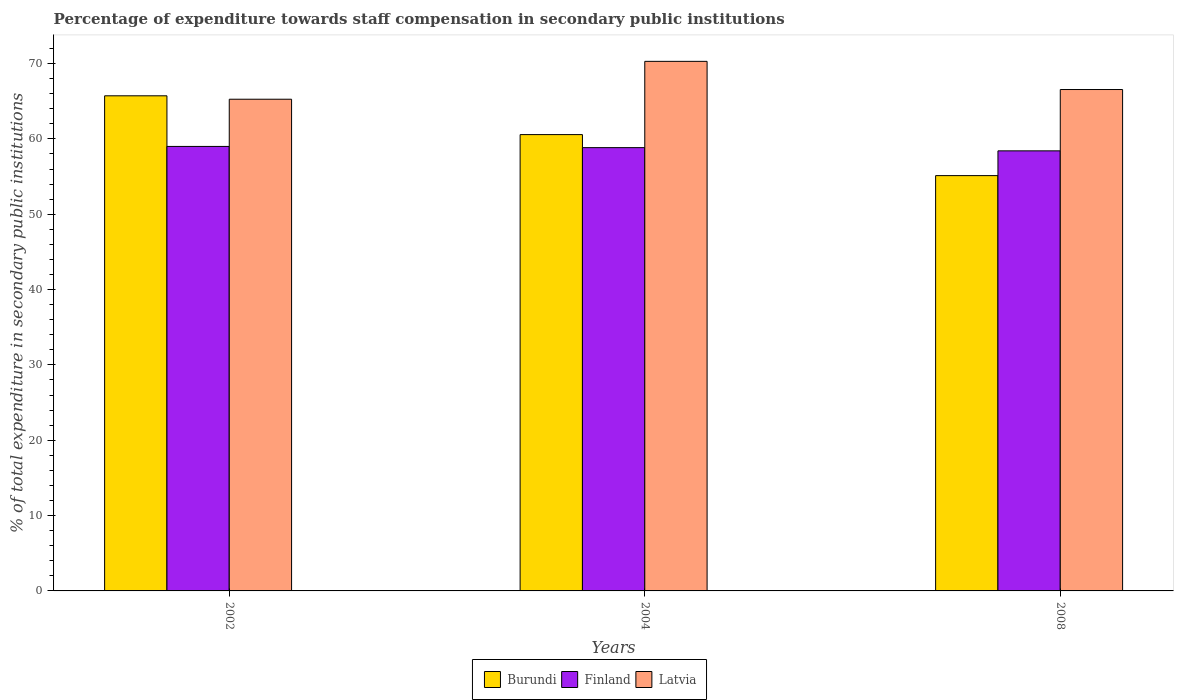How many groups of bars are there?
Ensure brevity in your answer.  3. Are the number of bars per tick equal to the number of legend labels?
Keep it short and to the point. Yes. Are the number of bars on each tick of the X-axis equal?
Make the answer very short. Yes. How many bars are there on the 2nd tick from the right?
Offer a terse response. 3. What is the label of the 3rd group of bars from the left?
Keep it short and to the point. 2008. What is the percentage of expenditure towards staff compensation in Latvia in 2008?
Your response must be concise. 66.56. Across all years, what is the maximum percentage of expenditure towards staff compensation in Burundi?
Make the answer very short. 65.72. Across all years, what is the minimum percentage of expenditure towards staff compensation in Latvia?
Give a very brief answer. 65.27. In which year was the percentage of expenditure towards staff compensation in Burundi maximum?
Offer a terse response. 2002. What is the total percentage of expenditure towards staff compensation in Latvia in the graph?
Make the answer very short. 202.12. What is the difference between the percentage of expenditure towards staff compensation in Finland in 2004 and that in 2008?
Offer a very short reply. 0.43. What is the difference between the percentage of expenditure towards staff compensation in Finland in 2008 and the percentage of expenditure towards staff compensation in Burundi in 2002?
Offer a very short reply. -7.31. What is the average percentage of expenditure towards staff compensation in Latvia per year?
Your answer should be compact. 67.37. In the year 2002, what is the difference between the percentage of expenditure towards staff compensation in Burundi and percentage of expenditure towards staff compensation in Finland?
Provide a succinct answer. 6.72. In how many years, is the percentage of expenditure towards staff compensation in Latvia greater than 54 %?
Your response must be concise. 3. What is the ratio of the percentage of expenditure towards staff compensation in Latvia in 2002 to that in 2004?
Your answer should be very brief. 0.93. Is the percentage of expenditure towards staff compensation in Latvia in 2002 less than that in 2008?
Ensure brevity in your answer.  Yes. What is the difference between the highest and the second highest percentage of expenditure towards staff compensation in Finland?
Provide a short and direct response. 0.16. What is the difference between the highest and the lowest percentage of expenditure towards staff compensation in Latvia?
Keep it short and to the point. 5.03. In how many years, is the percentage of expenditure towards staff compensation in Latvia greater than the average percentage of expenditure towards staff compensation in Latvia taken over all years?
Your answer should be compact. 1. What does the 1st bar from the left in 2002 represents?
Your response must be concise. Burundi. What does the 1st bar from the right in 2004 represents?
Your answer should be very brief. Latvia. Is it the case that in every year, the sum of the percentage of expenditure towards staff compensation in Burundi and percentage of expenditure towards staff compensation in Finland is greater than the percentage of expenditure towards staff compensation in Latvia?
Offer a terse response. Yes. Are all the bars in the graph horizontal?
Provide a short and direct response. No. How many years are there in the graph?
Provide a succinct answer. 3. Does the graph contain any zero values?
Your answer should be very brief. No. Does the graph contain grids?
Give a very brief answer. No. Where does the legend appear in the graph?
Give a very brief answer. Bottom center. What is the title of the graph?
Keep it short and to the point. Percentage of expenditure towards staff compensation in secondary public institutions. What is the label or title of the Y-axis?
Give a very brief answer. % of total expenditure in secondary public institutions. What is the % of total expenditure in secondary public institutions in Burundi in 2002?
Provide a succinct answer. 65.72. What is the % of total expenditure in secondary public institutions of Finland in 2002?
Your answer should be very brief. 59. What is the % of total expenditure in secondary public institutions of Latvia in 2002?
Offer a very short reply. 65.27. What is the % of total expenditure in secondary public institutions of Burundi in 2004?
Your answer should be compact. 60.57. What is the % of total expenditure in secondary public institutions in Finland in 2004?
Give a very brief answer. 58.84. What is the % of total expenditure in secondary public institutions of Latvia in 2004?
Make the answer very short. 70.3. What is the % of total expenditure in secondary public institutions of Burundi in 2008?
Your answer should be very brief. 55.13. What is the % of total expenditure in secondary public institutions in Finland in 2008?
Keep it short and to the point. 58.42. What is the % of total expenditure in secondary public institutions in Latvia in 2008?
Your answer should be very brief. 66.56. Across all years, what is the maximum % of total expenditure in secondary public institutions in Burundi?
Give a very brief answer. 65.72. Across all years, what is the maximum % of total expenditure in secondary public institutions in Finland?
Provide a succinct answer. 59. Across all years, what is the maximum % of total expenditure in secondary public institutions in Latvia?
Give a very brief answer. 70.3. Across all years, what is the minimum % of total expenditure in secondary public institutions of Burundi?
Provide a succinct answer. 55.13. Across all years, what is the minimum % of total expenditure in secondary public institutions in Finland?
Keep it short and to the point. 58.42. Across all years, what is the minimum % of total expenditure in secondary public institutions in Latvia?
Your response must be concise. 65.27. What is the total % of total expenditure in secondary public institutions in Burundi in the graph?
Offer a very short reply. 181.42. What is the total % of total expenditure in secondary public institutions in Finland in the graph?
Ensure brevity in your answer.  176.26. What is the total % of total expenditure in secondary public institutions of Latvia in the graph?
Your answer should be compact. 202.12. What is the difference between the % of total expenditure in secondary public institutions of Burundi in 2002 and that in 2004?
Your answer should be very brief. 5.15. What is the difference between the % of total expenditure in secondary public institutions in Finland in 2002 and that in 2004?
Keep it short and to the point. 0.16. What is the difference between the % of total expenditure in secondary public institutions of Latvia in 2002 and that in 2004?
Your answer should be very brief. -5.03. What is the difference between the % of total expenditure in secondary public institutions of Burundi in 2002 and that in 2008?
Your answer should be very brief. 10.59. What is the difference between the % of total expenditure in secondary public institutions of Finland in 2002 and that in 2008?
Keep it short and to the point. 0.59. What is the difference between the % of total expenditure in secondary public institutions of Latvia in 2002 and that in 2008?
Make the answer very short. -1.29. What is the difference between the % of total expenditure in secondary public institutions of Burundi in 2004 and that in 2008?
Ensure brevity in your answer.  5.44. What is the difference between the % of total expenditure in secondary public institutions of Finland in 2004 and that in 2008?
Give a very brief answer. 0.43. What is the difference between the % of total expenditure in secondary public institutions in Latvia in 2004 and that in 2008?
Your response must be concise. 3.74. What is the difference between the % of total expenditure in secondary public institutions of Burundi in 2002 and the % of total expenditure in secondary public institutions of Finland in 2004?
Your answer should be compact. 6.88. What is the difference between the % of total expenditure in secondary public institutions in Burundi in 2002 and the % of total expenditure in secondary public institutions in Latvia in 2004?
Offer a very short reply. -4.57. What is the difference between the % of total expenditure in secondary public institutions of Finland in 2002 and the % of total expenditure in secondary public institutions of Latvia in 2004?
Offer a terse response. -11.29. What is the difference between the % of total expenditure in secondary public institutions of Burundi in 2002 and the % of total expenditure in secondary public institutions of Finland in 2008?
Give a very brief answer. 7.31. What is the difference between the % of total expenditure in secondary public institutions of Burundi in 2002 and the % of total expenditure in secondary public institutions of Latvia in 2008?
Provide a succinct answer. -0.83. What is the difference between the % of total expenditure in secondary public institutions of Finland in 2002 and the % of total expenditure in secondary public institutions of Latvia in 2008?
Give a very brief answer. -7.55. What is the difference between the % of total expenditure in secondary public institutions in Burundi in 2004 and the % of total expenditure in secondary public institutions in Finland in 2008?
Your answer should be very brief. 2.16. What is the difference between the % of total expenditure in secondary public institutions in Burundi in 2004 and the % of total expenditure in secondary public institutions in Latvia in 2008?
Provide a succinct answer. -5.98. What is the difference between the % of total expenditure in secondary public institutions of Finland in 2004 and the % of total expenditure in secondary public institutions of Latvia in 2008?
Your response must be concise. -7.71. What is the average % of total expenditure in secondary public institutions in Burundi per year?
Make the answer very short. 60.47. What is the average % of total expenditure in secondary public institutions in Finland per year?
Make the answer very short. 58.75. What is the average % of total expenditure in secondary public institutions in Latvia per year?
Provide a succinct answer. 67.37. In the year 2002, what is the difference between the % of total expenditure in secondary public institutions of Burundi and % of total expenditure in secondary public institutions of Finland?
Your answer should be compact. 6.72. In the year 2002, what is the difference between the % of total expenditure in secondary public institutions in Burundi and % of total expenditure in secondary public institutions in Latvia?
Provide a succinct answer. 0.45. In the year 2002, what is the difference between the % of total expenditure in secondary public institutions of Finland and % of total expenditure in secondary public institutions of Latvia?
Keep it short and to the point. -6.27. In the year 2004, what is the difference between the % of total expenditure in secondary public institutions in Burundi and % of total expenditure in secondary public institutions in Finland?
Keep it short and to the point. 1.73. In the year 2004, what is the difference between the % of total expenditure in secondary public institutions in Burundi and % of total expenditure in secondary public institutions in Latvia?
Offer a terse response. -9.72. In the year 2004, what is the difference between the % of total expenditure in secondary public institutions in Finland and % of total expenditure in secondary public institutions in Latvia?
Your response must be concise. -11.45. In the year 2008, what is the difference between the % of total expenditure in secondary public institutions of Burundi and % of total expenditure in secondary public institutions of Finland?
Offer a terse response. -3.29. In the year 2008, what is the difference between the % of total expenditure in secondary public institutions of Burundi and % of total expenditure in secondary public institutions of Latvia?
Provide a short and direct response. -11.43. In the year 2008, what is the difference between the % of total expenditure in secondary public institutions in Finland and % of total expenditure in secondary public institutions in Latvia?
Offer a very short reply. -8.14. What is the ratio of the % of total expenditure in secondary public institutions of Burundi in 2002 to that in 2004?
Your answer should be compact. 1.08. What is the ratio of the % of total expenditure in secondary public institutions of Latvia in 2002 to that in 2004?
Ensure brevity in your answer.  0.93. What is the ratio of the % of total expenditure in secondary public institutions in Burundi in 2002 to that in 2008?
Your response must be concise. 1.19. What is the ratio of the % of total expenditure in secondary public institutions in Finland in 2002 to that in 2008?
Provide a succinct answer. 1.01. What is the ratio of the % of total expenditure in secondary public institutions in Latvia in 2002 to that in 2008?
Provide a succinct answer. 0.98. What is the ratio of the % of total expenditure in secondary public institutions in Burundi in 2004 to that in 2008?
Your response must be concise. 1.1. What is the ratio of the % of total expenditure in secondary public institutions in Finland in 2004 to that in 2008?
Provide a succinct answer. 1.01. What is the ratio of the % of total expenditure in secondary public institutions in Latvia in 2004 to that in 2008?
Make the answer very short. 1.06. What is the difference between the highest and the second highest % of total expenditure in secondary public institutions of Burundi?
Provide a succinct answer. 5.15. What is the difference between the highest and the second highest % of total expenditure in secondary public institutions in Finland?
Provide a short and direct response. 0.16. What is the difference between the highest and the second highest % of total expenditure in secondary public institutions of Latvia?
Your answer should be compact. 3.74. What is the difference between the highest and the lowest % of total expenditure in secondary public institutions of Burundi?
Give a very brief answer. 10.59. What is the difference between the highest and the lowest % of total expenditure in secondary public institutions in Finland?
Ensure brevity in your answer.  0.59. What is the difference between the highest and the lowest % of total expenditure in secondary public institutions in Latvia?
Ensure brevity in your answer.  5.03. 